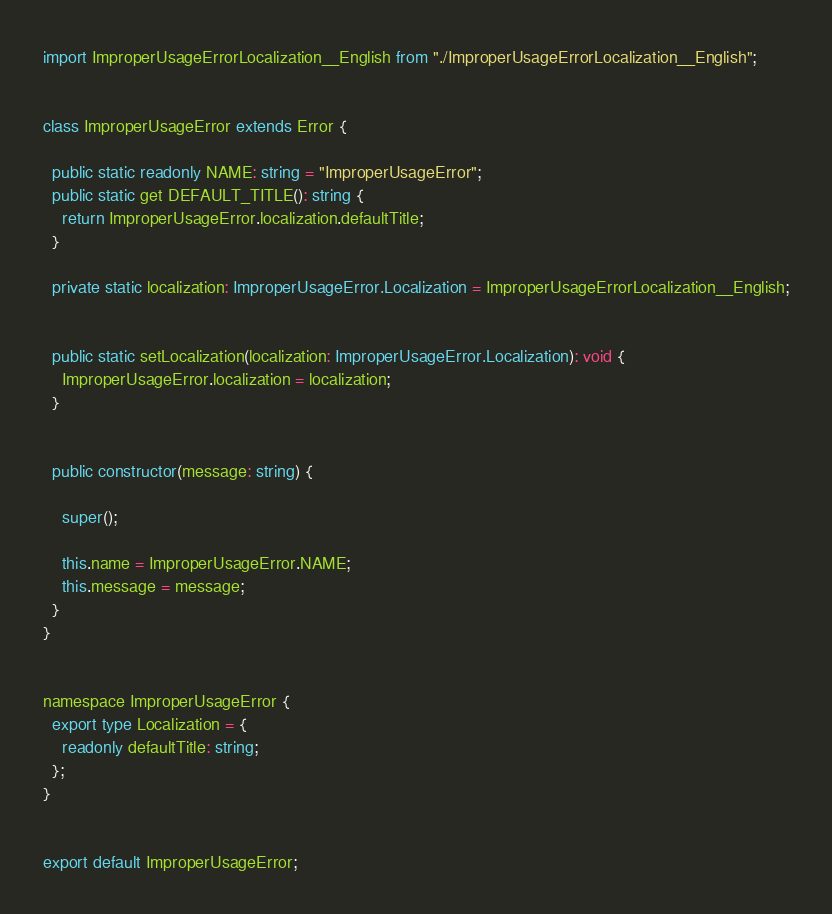Convert code to text. <code><loc_0><loc_0><loc_500><loc_500><_TypeScript_>import ImproperUsageErrorLocalization__English from "./ImproperUsageErrorLocalization__English";


class ImproperUsageError extends Error {

  public static readonly NAME: string = "ImproperUsageError";
  public static get DEFAULT_TITLE(): string {
    return ImproperUsageError.localization.defaultTitle;
  }

  private static localization: ImproperUsageError.Localization = ImproperUsageErrorLocalization__English;


  public static setLocalization(localization: ImproperUsageError.Localization): void {
    ImproperUsageError.localization = localization;
  }


  public constructor(message: string) {

    super();

    this.name = ImproperUsageError.NAME;
    this.message = message;
  }
}


namespace ImproperUsageError {
  export type Localization = {
    readonly defaultTitle: string;
  };
}


export default ImproperUsageError;
</code> 